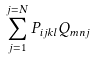<formula> <loc_0><loc_0><loc_500><loc_500>\sum _ { j = 1 } ^ { j = N } P _ { i j k l } Q _ { m n j }</formula> 